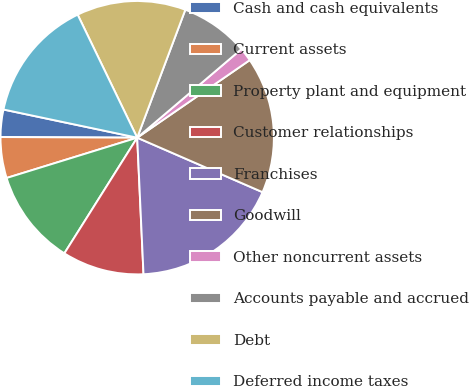<chart> <loc_0><loc_0><loc_500><loc_500><pie_chart><fcel>Cash and cash equivalents<fcel>Current assets<fcel>Property plant and equipment<fcel>Customer relationships<fcel>Franchises<fcel>Goodwill<fcel>Other noncurrent assets<fcel>Accounts payable and accrued<fcel>Debt<fcel>Deferred income taxes<nl><fcel>3.23%<fcel>4.84%<fcel>11.29%<fcel>9.68%<fcel>17.74%<fcel>16.13%<fcel>1.61%<fcel>8.06%<fcel>12.9%<fcel>14.52%<nl></chart> 